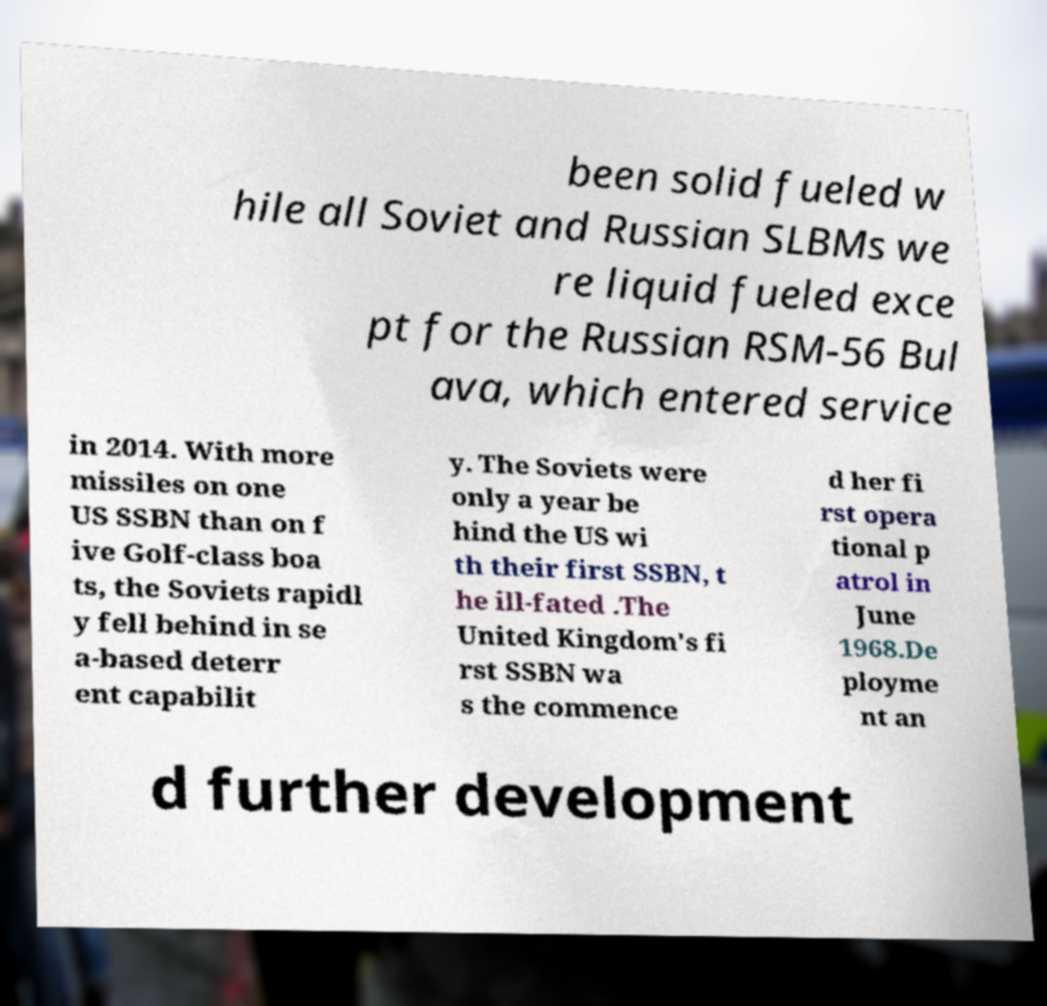Could you assist in decoding the text presented in this image and type it out clearly? been solid fueled w hile all Soviet and Russian SLBMs we re liquid fueled exce pt for the Russian RSM-56 Bul ava, which entered service in 2014. With more missiles on one US SSBN than on f ive Golf-class boa ts, the Soviets rapidl y fell behind in se a-based deterr ent capabilit y. The Soviets were only a year be hind the US wi th their first SSBN, t he ill-fated .The United Kingdom's fi rst SSBN wa s the commence d her fi rst opera tional p atrol in June 1968.De ployme nt an d further development 